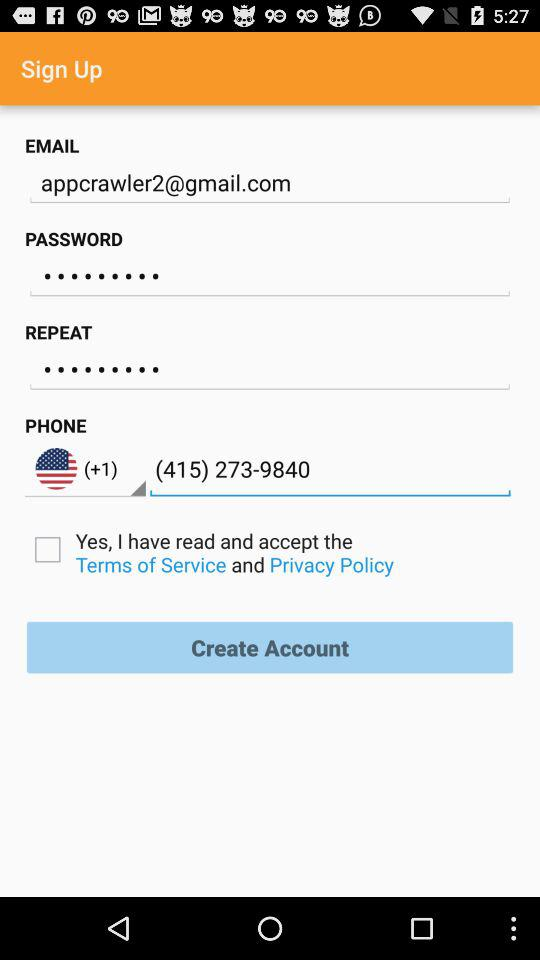Which country codes are available in the drop-down menu?
When the provided information is insufficient, respond with <no answer>. <no answer> 